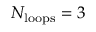Convert formula to latex. <formula><loc_0><loc_0><loc_500><loc_500>N _ { l o o p s } = 3</formula> 